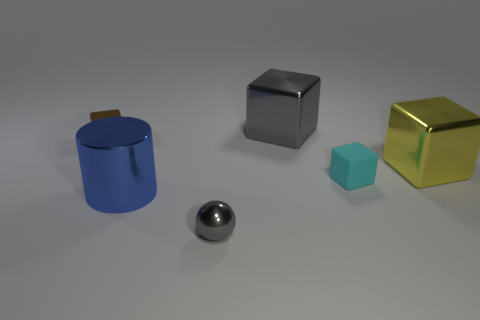What is the shape of the metallic object that is the same color as the metallic sphere?
Offer a very short reply. Cube. Is there a large block that has the same color as the sphere?
Give a very brief answer. Yes. The cube that is the same color as the small shiny sphere is what size?
Give a very brief answer. Large. What is the shape of the small matte thing?
Provide a short and direct response. Cube. What shape is the shiny object that is behind the tiny shiny object behind the big cube in front of the large gray thing?
Provide a succinct answer. Cube. How many other objects are there of the same shape as the small gray object?
Give a very brief answer. 0. The tiny block in front of the metal object that is to the left of the metal cylinder is made of what material?
Offer a terse response. Rubber. Are the big yellow object and the tiny gray ball in front of the small brown cube made of the same material?
Give a very brief answer. Yes. What is the material of the thing that is both behind the yellow metallic cube and on the left side of the shiny ball?
Keep it short and to the point. Metal. The cube that is left of the block that is behind the tiny brown metal thing is what color?
Offer a very short reply. Brown. 